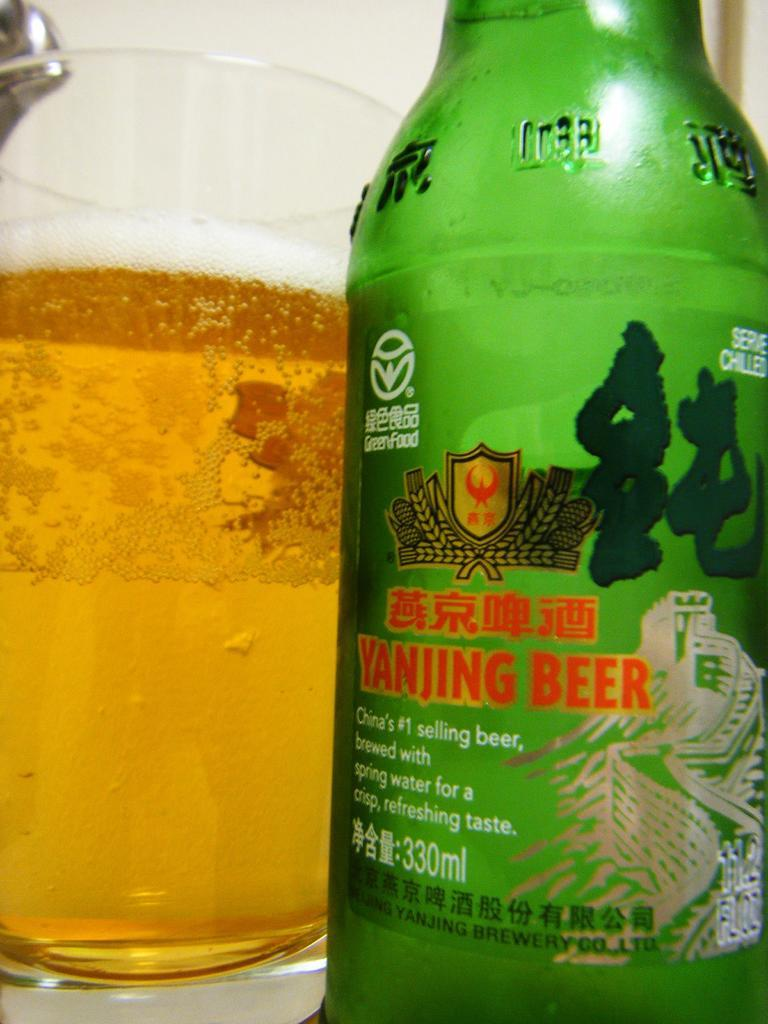<image>
Render a clear and concise summary of the photo. A close up shot of a Yanjing Beer bottle in front of a glass of beer. 